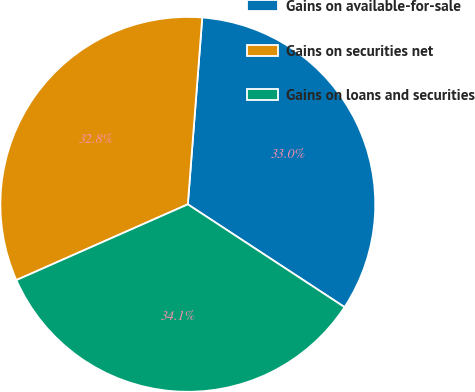<chart> <loc_0><loc_0><loc_500><loc_500><pie_chart><fcel>Gains on available-for-sale<fcel>Gains on securities net<fcel>Gains on loans and securities<nl><fcel>33.01%<fcel>32.85%<fcel>34.14%<nl></chart> 